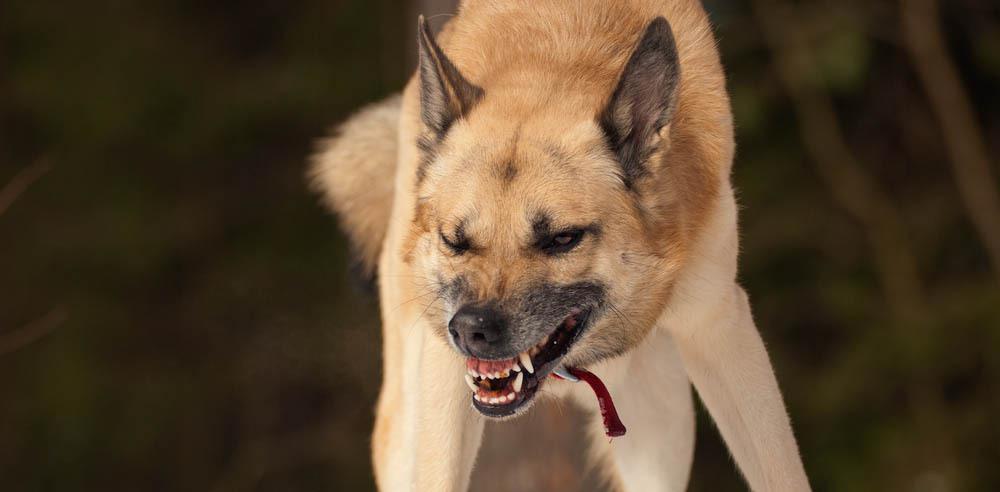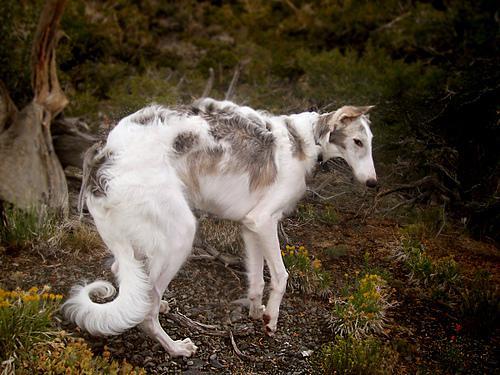The first image is the image on the left, the second image is the image on the right. Considering the images on both sides, is "One dog is sitting on its bottom." valid? Answer yes or no. No. The first image is the image on the left, the second image is the image on the right. Considering the images on both sides, is "One of the dogs is sitting on its haunches." valid? Answer yes or no. No. 